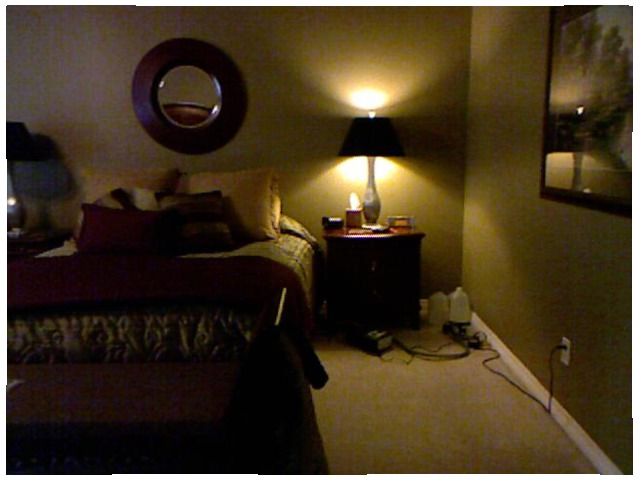<image>
Can you confirm if the light is on the wall? Yes. Looking at the image, I can see the light is positioned on top of the wall, with the wall providing support. Is the lamp under the mirror? No. The lamp is not positioned under the mirror. The vertical relationship between these objects is different. 